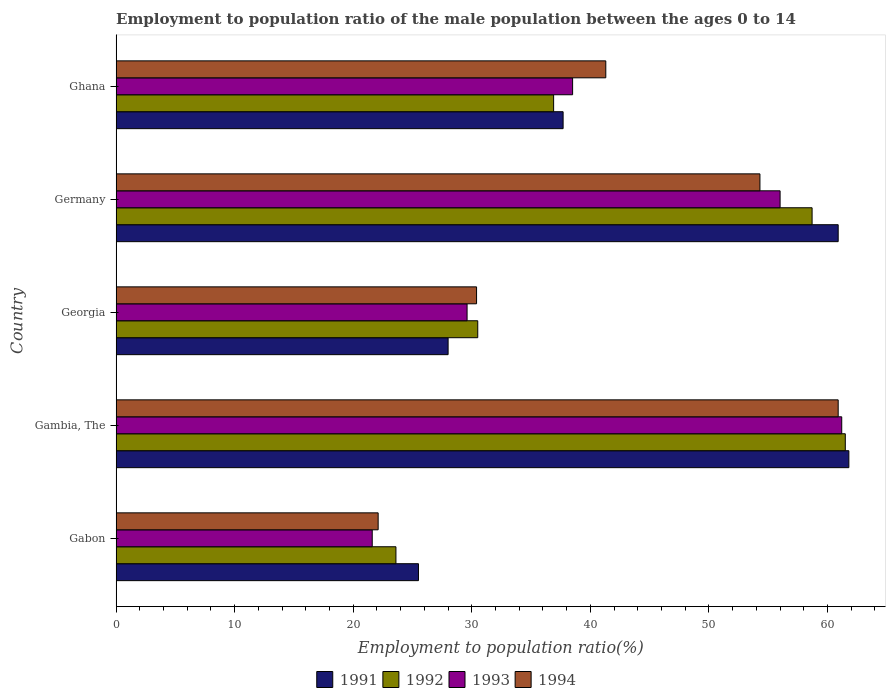How many groups of bars are there?
Provide a short and direct response. 5. How many bars are there on the 1st tick from the top?
Your answer should be compact. 4. In how many cases, is the number of bars for a given country not equal to the number of legend labels?
Offer a terse response. 0. What is the employment to population ratio in 1992 in Germany?
Your response must be concise. 58.7. Across all countries, what is the maximum employment to population ratio in 1991?
Your answer should be compact. 61.8. Across all countries, what is the minimum employment to population ratio in 1993?
Ensure brevity in your answer.  21.6. In which country was the employment to population ratio in 1991 maximum?
Give a very brief answer. Gambia, The. In which country was the employment to population ratio in 1994 minimum?
Ensure brevity in your answer.  Gabon. What is the total employment to population ratio in 1994 in the graph?
Provide a succinct answer. 209. What is the difference between the employment to population ratio in 1994 in Gambia, The and that in Georgia?
Your response must be concise. 30.5. What is the difference between the employment to population ratio in 1993 in Ghana and the employment to population ratio in 1992 in Gabon?
Offer a very short reply. 14.9. What is the average employment to population ratio in 1992 per country?
Your answer should be very brief. 42.24. What is the difference between the employment to population ratio in 1992 and employment to population ratio in 1993 in Georgia?
Your answer should be compact. 0.9. What is the ratio of the employment to population ratio in 1993 in Gabon to that in Gambia, The?
Give a very brief answer. 0.35. What is the difference between the highest and the second highest employment to population ratio in 1992?
Give a very brief answer. 2.8. What is the difference between the highest and the lowest employment to population ratio in 1994?
Offer a terse response. 38.8. Is the sum of the employment to population ratio in 1991 in Gabon and Georgia greater than the maximum employment to population ratio in 1994 across all countries?
Make the answer very short. No. What does the 4th bar from the bottom in Germany represents?
Keep it short and to the point. 1994. How many countries are there in the graph?
Offer a terse response. 5. What is the difference between two consecutive major ticks on the X-axis?
Offer a terse response. 10. Where does the legend appear in the graph?
Ensure brevity in your answer.  Bottom center. What is the title of the graph?
Ensure brevity in your answer.  Employment to population ratio of the male population between the ages 0 to 14. What is the label or title of the X-axis?
Offer a very short reply. Employment to population ratio(%). What is the Employment to population ratio(%) of 1991 in Gabon?
Give a very brief answer. 25.5. What is the Employment to population ratio(%) in 1992 in Gabon?
Your answer should be compact. 23.6. What is the Employment to population ratio(%) in 1993 in Gabon?
Your response must be concise. 21.6. What is the Employment to population ratio(%) of 1994 in Gabon?
Ensure brevity in your answer.  22.1. What is the Employment to population ratio(%) in 1991 in Gambia, The?
Offer a terse response. 61.8. What is the Employment to population ratio(%) of 1992 in Gambia, The?
Offer a terse response. 61.5. What is the Employment to population ratio(%) of 1993 in Gambia, The?
Provide a succinct answer. 61.2. What is the Employment to population ratio(%) of 1994 in Gambia, The?
Your response must be concise. 60.9. What is the Employment to population ratio(%) in 1992 in Georgia?
Make the answer very short. 30.5. What is the Employment to population ratio(%) of 1993 in Georgia?
Your answer should be compact. 29.6. What is the Employment to population ratio(%) in 1994 in Georgia?
Provide a succinct answer. 30.4. What is the Employment to population ratio(%) of 1991 in Germany?
Your answer should be very brief. 60.9. What is the Employment to population ratio(%) in 1992 in Germany?
Your response must be concise. 58.7. What is the Employment to population ratio(%) in 1993 in Germany?
Give a very brief answer. 56. What is the Employment to population ratio(%) of 1994 in Germany?
Make the answer very short. 54.3. What is the Employment to population ratio(%) in 1991 in Ghana?
Keep it short and to the point. 37.7. What is the Employment to population ratio(%) in 1992 in Ghana?
Provide a short and direct response. 36.9. What is the Employment to population ratio(%) in 1993 in Ghana?
Offer a very short reply. 38.5. What is the Employment to population ratio(%) of 1994 in Ghana?
Offer a very short reply. 41.3. Across all countries, what is the maximum Employment to population ratio(%) in 1991?
Provide a succinct answer. 61.8. Across all countries, what is the maximum Employment to population ratio(%) of 1992?
Your answer should be very brief. 61.5. Across all countries, what is the maximum Employment to population ratio(%) of 1993?
Give a very brief answer. 61.2. Across all countries, what is the maximum Employment to population ratio(%) of 1994?
Your answer should be very brief. 60.9. Across all countries, what is the minimum Employment to population ratio(%) of 1992?
Keep it short and to the point. 23.6. Across all countries, what is the minimum Employment to population ratio(%) in 1993?
Your answer should be very brief. 21.6. Across all countries, what is the minimum Employment to population ratio(%) of 1994?
Your answer should be compact. 22.1. What is the total Employment to population ratio(%) in 1991 in the graph?
Make the answer very short. 213.9. What is the total Employment to population ratio(%) in 1992 in the graph?
Ensure brevity in your answer.  211.2. What is the total Employment to population ratio(%) of 1993 in the graph?
Your response must be concise. 206.9. What is the total Employment to population ratio(%) in 1994 in the graph?
Make the answer very short. 209. What is the difference between the Employment to population ratio(%) of 1991 in Gabon and that in Gambia, The?
Give a very brief answer. -36.3. What is the difference between the Employment to population ratio(%) of 1992 in Gabon and that in Gambia, The?
Your response must be concise. -37.9. What is the difference between the Employment to population ratio(%) of 1993 in Gabon and that in Gambia, The?
Your answer should be compact. -39.6. What is the difference between the Employment to population ratio(%) of 1994 in Gabon and that in Gambia, The?
Keep it short and to the point. -38.8. What is the difference between the Employment to population ratio(%) in 1992 in Gabon and that in Georgia?
Your answer should be compact. -6.9. What is the difference between the Employment to population ratio(%) of 1993 in Gabon and that in Georgia?
Provide a succinct answer. -8. What is the difference between the Employment to population ratio(%) of 1991 in Gabon and that in Germany?
Offer a terse response. -35.4. What is the difference between the Employment to population ratio(%) of 1992 in Gabon and that in Germany?
Keep it short and to the point. -35.1. What is the difference between the Employment to population ratio(%) of 1993 in Gabon and that in Germany?
Keep it short and to the point. -34.4. What is the difference between the Employment to population ratio(%) in 1994 in Gabon and that in Germany?
Your response must be concise. -32.2. What is the difference between the Employment to population ratio(%) in 1992 in Gabon and that in Ghana?
Offer a terse response. -13.3. What is the difference between the Employment to population ratio(%) in 1993 in Gabon and that in Ghana?
Offer a terse response. -16.9. What is the difference between the Employment to population ratio(%) in 1994 in Gabon and that in Ghana?
Give a very brief answer. -19.2. What is the difference between the Employment to population ratio(%) of 1991 in Gambia, The and that in Georgia?
Your response must be concise. 33.8. What is the difference between the Employment to population ratio(%) in 1993 in Gambia, The and that in Georgia?
Give a very brief answer. 31.6. What is the difference between the Employment to population ratio(%) in 1994 in Gambia, The and that in Georgia?
Offer a terse response. 30.5. What is the difference between the Employment to population ratio(%) of 1993 in Gambia, The and that in Germany?
Make the answer very short. 5.2. What is the difference between the Employment to population ratio(%) of 1991 in Gambia, The and that in Ghana?
Keep it short and to the point. 24.1. What is the difference between the Employment to population ratio(%) of 1992 in Gambia, The and that in Ghana?
Your answer should be compact. 24.6. What is the difference between the Employment to population ratio(%) of 1993 in Gambia, The and that in Ghana?
Give a very brief answer. 22.7. What is the difference between the Employment to population ratio(%) of 1994 in Gambia, The and that in Ghana?
Offer a very short reply. 19.6. What is the difference between the Employment to population ratio(%) in 1991 in Georgia and that in Germany?
Give a very brief answer. -32.9. What is the difference between the Employment to population ratio(%) in 1992 in Georgia and that in Germany?
Give a very brief answer. -28.2. What is the difference between the Employment to population ratio(%) in 1993 in Georgia and that in Germany?
Provide a succinct answer. -26.4. What is the difference between the Employment to population ratio(%) of 1994 in Georgia and that in Germany?
Offer a terse response. -23.9. What is the difference between the Employment to population ratio(%) of 1992 in Georgia and that in Ghana?
Ensure brevity in your answer.  -6.4. What is the difference between the Employment to population ratio(%) of 1993 in Georgia and that in Ghana?
Offer a very short reply. -8.9. What is the difference between the Employment to population ratio(%) of 1991 in Germany and that in Ghana?
Ensure brevity in your answer.  23.2. What is the difference between the Employment to population ratio(%) in 1992 in Germany and that in Ghana?
Offer a very short reply. 21.8. What is the difference between the Employment to population ratio(%) in 1991 in Gabon and the Employment to population ratio(%) in 1992 in Gambia, The?
Your response must be concise. -36. What is the difference between the Employment to population ratio(%) in 1991 in Gabon and the Employment to population ratio(%) in 1993 in Gambia, The?
Give a very brief answer. -35.7. What is the difference between the Employment to population ratio(%) in 1991 in Gabon and the Employment to population ratio(%) in 1994 in Gambia, The?
Keep it short and to the point. -35.4. What is the difference between the Employment to population ratio(%) in 1992 in Gabon and the Employment to population ratio(%) in 1993 in Gambia, The?
Give a very brief answer. -37.6. What is the difference between the Employment to population ratio(%) in 1992 in Gabon and the Employment to population ratio(%) in 1994 in Gambia, The?
Ensure brevity in your answer.  -37.3. What is the difference between the Employment to population ratio(%) in 1993 in Gabon and the Employment to population ratio(%) in 1994 in Gambia, The?
Provide a succinct answer. -39.3. What is the difference between the Employment to population ratio(%) of 1991 in Gabon and the Employment to population ratio(%) of 1992 in Germany?
Offer a very short reply. -33.2. What is the difference between the Employment to population ratio(%) of 1991 in Gabon and the Employment to population ratio(%) of 1993 in Germany?
Make the answer very short. -30.5. What is the difference between the Employment to population ratio(%) of 1991 in Gabon and the Employment to population ratio(%) of 1994 in Germany?
Your response must be concise. -28.8. What is the difference between the Employment to population ratio(%) in 1992 in Gabon and the Employment to population ratio(%) in 1993 in Germany?
Provide a short and direct response. -32.4. What is the difference between the Employment to population ratio(%) in 1992 in Gabon and the Employment to population ratio(%) in 1994 in Germany?
Provide a short and direct response. -30.7. What is the difference between the Employment to population ratio(%) in 1993 in Gabon and the Employment to population ratio(%) in 1994 in Germany?
Give a very brief answer. -32.7. What is the difference between the Employment to population ratio(%) of 1991 in Gabon and the Employment to population ratio(%) of 1992 in Ghana?
Keep it short and to the point. -11.4. What is the difference between the Employment to population ratio(%) in 1991 in Gabon and the Employment to population ratio(%) in 1993 in Ghana?
Offer a terse response. -13. What is the difference between the Employment to population ratio(%) in 1991 in Gabon and the Employment to population ratio(%) in 1994 in Ghana?
Your response must be concise. -15.8. What is the difference between the Employment to population ratio(%) in 1992 in Gabon and the Employment to population ratio(%) in 1993 in Ghana?
Give a very brief answer. -14.9. What is the difference between the Employment to population ratio(%) of 1992 in Gabon and the Employment to population ratio(%) of 1994 in Ghana?
Make the answer very short. -17.7. What is the difference between the Employment to population ratio(%) of 1993 in Gabon and the Employment to population ratio(%) of 1994 in Ghana?
Ensure brevity in your answer.  -19.7. What is the difference between the Employment to population ratio(%) in 1991 in Gambia, The and the Employment to population ratio(%) in 1992 in Georgia?
Keep it short and to the point. 31.3. What is the difference between the Employment to population ratio(%) in 1991 in Gambia, The and the Employment to population ratio(%) in 1993 in Georgia?
Provide a short and direct response. 32.2. What is the difference between the Employment to population ratio(%) in 1991 in Gambia, The and the Employment to population ratio(%) in 1994 in Georgia?
Provide a succinct answer. 31.4. What is the difference between the Employment to population ratio(%) in 1992 in Gambia, The and the Employment to population ratio(%) in 1993 in Georgia?
Give a very brief answer. 31.9. What is the difference between the Employment to population ratio(%) in 1992 in Gambia, The and the Employment to population ratio(%) in 1994 in Georgia?
Your answer should be very brief. 31.1. What is the difference between the Employment to population ratio(%) in 1993 in Gambia, The and the Employment to population ratio(%) in 1994 in Georgia?
Your answer should be very brief. 30.8. What is the difference between the Employment to population ratio(%) of 1991 in Gambia, The and the Employment to population ratio(%) of 1992 in Germany?
Your answer should be very brief. 3.1. What is the difference between the Employment to population ratio(%) in 1992 in Gambia, The and the Employment to population ratio(%) in 1993 in Germany?
Your answer should be very brief. 5.5. What is the difference between the Employment to population ratio(%) in 1992 in Gambia, The and the Employment to population ratio(%) in 1994 in Germany?
Your answer should be very brief. 7.2. What is the difference between the Employment to population ratio(%) of 1991 in Gambia, The and the Employment to population ratio(%) of 1992 in Ghana?
Provide a succinct answer. 24.9. What is the difference between the Employment to population ratio(%) of 1991 in Gambia, The and the Employment to population ratio(%) of 1993 in Ghana?
Your answer should be compact. 23.3. What is the difference between the Employment to population ratio(%) in 1991 in Gambia, The and the Employment to population ratio(%) in 1994 in Ghana?
Your answer should be compact. 20.5. What is the difference between the Employment to population ratio(%) of 1992 in Gambia, The and the Employment to population ratio(%) of 1993 in Ghana?
Your answer should be compact. 23. What is the difference between the Employment to population ratio(%) in 1992 in Gambia, The and the Employment to population ratio(%) in 1994 in Ghana?
Your answer should be very brief. 20.2. What is the difference between the Employment to population ratio(%) in 1991 in Georgia and the Employment to population ratio(%) in 1992 in Germany?
Your answer should be very brief. -30.7. What is the difference between the Employment to population ratio(%) of 1991 in Georgia and the Employment to population ratio(%) of 1993 in Germany?
Offer a very short reply. -28. What is the difference between the Employment to population ratio(%) of 1991 in Georgia and the Employment to population ratio(%) of 1994 in Germany?
Your response must be concise. -26.3. What is the difference between the Employment to population ratio(%) of 1992 in Georgia and the Employment to population ratio(%) of 1993 in Germany?
Your answer should be compact. -25.5. What is the difference between the Employment to population ratio(%) of 1992 in Georgia and the Employment to population ratio(%) of 1994 in Germany?
Ensure brevity in your answer.  -23.8. What is the difference between the Employment to population ratio(%) in 1993 in Georgia and the Employment to population ratio(%) in 1994 in Germany?
Ensure brevity in your answer.  -24.7. What is the difference between the Employment to population ratio(%) of 1991 in Georgia and the Employment to population ratio(%) of 1992 in Ghana?
Ensure brevity in your answer.  -8.9. What is the difference between the Employment to population ratio(%) of 1991 in Georgia and the Employment to population ratio(%) of 1993 in Ghana?
Make the answer very short. -10.5. What is the difference between the Employment to population ratio(%) in 1992 in Georgia and the Employment to population ratio(%) in 1993 in Ghana?
Your response must be concise. -8. What is the difference between the Employment to population ratio(%) of 1991 in Germany and the Employment to population ratio(%) of 1992 in Ghana?
Your answer should be very brief. 24. What is the difference between the Employment to population ratio(%) of 1991 in Germany and the Employment to population ratio(%) of 1993 in Ghana?
Give a very brief answer. 22.4. What is the difference between the Employment to population ratio(%) of 1991 in Germany and the Employment to population ratio(%) of 1994 in Ghana?
Ensure brevity in your answer.  19.6. What is the difference between the Employment to population ratio(%) in 1992 in Germany and the Employment to population ratio(%) in 1993 in Ghana?
Ensure brevity in your answer.  20.2. What is the average Employment to population ratio(%) of 1991 per country?
Offer a terse response. 42.78. What is the average Employment to population ratio(%) of 1992 per country?
Provide a succinct answer. 42.24. What is the average Employment to population ratio(%) in 1993 per country?
Ensure brevity in your answer.  41.38. What is the average Employment to population ratio(%) of 1994 per country?
Make the answer very short. 41.8. What is the difference between the Employment to population ratio(%) in 1991 and Employment to population ratio(%) in 1992 in Gabon?
Offer a very short reply. 1.9. What is the difference between the Employment to population ratio(%) of 1991 and Employment to population ratio(%) of 1993 in Gabon?
Keep it short and to the point. 3.9. What is the difference between the Employment to population ratio(%) of 1992 and Employment to population ratio(%) of 1993 in Gabon?
Make the answer very short. 2. What is the difference between the Employment to population ratio(%) in 1992 and Employment to population ratio(%) in 1994 in Gabon?
Your answer should be compact. 1.5. What is the difference between the Employment to population ratio(%) in 1993 and Employment to population ratio(%) in 1994 in Gabon?
Provide a succinct answer. -0.5. What is the difference between the Employment to population ratio(%) in 1991 and Employment to population ratio(%) in 1992 in Gambia, The?
Offer a terse response. 0.3. What is the difference between the Employment to population ratio(%) in 1991 and Employment to population ratio(%) in 1993 in Gambia, The?
Offer a very short reply. 0.6. What is the difference between the Employment to population ratio(%) in 1992 and Employment to population ratio(%) in 1994 in Gambia, The?
Offer a very short reply. 0.6. What is the difference between the Employment to population ratio(%) in 1993 and Employment to population ratio(%) in 1994 in Gambia, The?
Give a very brief answer. 0.3. What is the difference between the Employment to population ratio(%) of 1991 and Employment to population ratio(%) of 1992 in Georgia?
Offer a terse response. -2.5. What is the difference between the Employment to population ratio(%) in 1992 and Employment to population ratio(%) in 1993 in Georgia?
Your answer should be compact. 0.9. What is the difference between the Employment to population ratio(%) of 1992 and Employment to population ratio(%) of 1994 in Georgia?
Provide a succinct answer. 0.1. What is the difference between the Employment to population ratio(%) in 1993 and Employment to population ratio(%) in 1994 in Georgia?
Make the answer very short. -0.8. What is the difference between the Employment to population ratio(%) in 1991 and Employment to population ratio(%) in 1992 in Germany?
Offer a terse response. 2.2. What is the difference between the Employment to population ratio(%) in 1991 and Employment to population ratio(%) in 1993 in Germany?
Your answer should be very brief. 4.9. What is the difference between the Employment to population ratio(%) in 1991 and Employment to population ratio(%) in 1994 in Germany?
Ensure brevity in your answer.  6.6. What is the difference between the Employment to population ratio(%) in 1991 and Employment to population ratio(%) in 1993 in Ghana?
Provide a short and direct response. -0.8. What is the difference between the Employment to population ratio(%) of 1991 and Employment to population ratio(%) of 1994 in Ghana?
Keep it short and to the point. -3.6. What is the difference between the Employment to population ratio(%) in 1992 and Employment to population ratio(%) in 1993 in Ghana?
Make the answer very short. -1.6. What is the difference between the Employment to population ratio(%) in 1992 and Employment to population ratio(%) in 1994 in Ghana?
Your answer should be very brief. -4.4. What is the ratio of the Employment to population ratio(%) in 1991 in Gabon to that in Gambia, The?
Provide a short and direct response. 0.41. What is the ratio of the Employment to population ratio(%) of 1992 in Gabon to that in Gambia, The?
Your response must be concise. 0.38. What is the ratio of the Employment to population ratio(%) in 1993 in Gabon to that in Gambia, The?
Your response must be concise. 0.35. What is the ratio of the Employment to population ratio(%) of 1994 in Gabon to that in Gambia, The?
Provide a short and direct response. 0.36. What is the ratio of the Employment to population ratio(%) in 1991 in Gabon to that in Georgia?
Make the answer very short. 0.91. What is the ratio of the Employment to population ratio(%) of 1992 in Gabon to that in Georgia?
Keep it short and to the point. 0.77. What is the ratio of the Employment to population ratio(%) of 1993 in Gabon to that in Georgia?
Make the answer very short. 0.73. What is the ratio of the Employment to population ratio(%) of 1994 in Gabon to that in Georgia?
Keep it short and to the point. 0.73. What is the ratio of the Employment to population ratio(%) of 1991 in Gabon to that in Germany?
Give a very brief answer. 0.42. What is the ratio of the Employment to population ratio(%) in 1992 in Gabon to that in Germany?
Keep it short and to the point. 0.4. What is the ratio of the Employment to population ratio(%) in 1993 in Gabon to that in Germany?
Provide a short and direct response. 0.39. What is the ratio of the Employment to population ratio(%) of 1994 in Gabon to that in Germany?
Keep it short and to the point. 0.41. What is the ratio of the Employment to population ratio(%) of 1991 in Gabon to that in Ghana?
Give a very brief answer. 0.68. What is the ratio of the Employment to population ratio(%) in 1992 in Gabon to that in Ghana?
Your response must be concise. 0.64. What is the ratio of the Employment to population ratio(%) in 1993 in Gabon to that in Ghana?
Make the answer very short. 0.56. What is the ratio of the Employment to population ratio(%) of 1994 in Gabon to that in Ghana?
Keep it short and to the point. 0.54. What is the ratio of the Employment to population ratio(%) in 1991 in Gambia, The to that in Georgia?
Your answer should be compact. 2.21. What is the ratio of the Employment to population ratio(%) of 1992 in Gambia, The to that in Georgia?
Your answer should be compact. 2.02. What is the ratio of the Employment to population ratio(%) in 1993 in Gambia, The to that in Georgia?
Your answer should be compact. 2.07. What is the ratio of the Employment to population ratio(%) in 1994 in Gambia, The to that in Georgia?
Offer a terse response. 2. What is the ratio of the Employment to population ratio(%) of 1991 in Gambia, The to that in Germany?
Provide a short and direct response. 1.01. What is the ratio of the Employment to population ratio(%) in 1992 in Gambia, The to that in Germany?
Provide a short and direct response. 1.05. What is the ratio of the Employment to population ratio(%) in 1993 in Gambia, The to that in Germany?
Offer a terse response. 1.09. What is the ratio of the Employment to population ratio(%) of 1994 in Gambia, The to that in Germany?
Your answer should be compact. 1.12. What is the ratio of the Employment to population ratio(%) of 1991 in Gambia, The to that in Ghana?
Keep it short and to the point. 1.64. What is the ratio of the Employment to population ratio(%) in 1992 in Gambia, The to that in Ghana?
Your response must be concise. 1.67. What is the ratio of the Employment to population ratio(%) of 1993 in Gambia, The to that in Ghana?
Offer a terse response. 1.59. What is the ratio of the Employment to population ratio(%) in 1994 in Gambia, The to that in Ghana?
Make the answer very short. 1.47. What is the ratio of the Employment to population ratio(%) of 1991 in Georgia to that in Germany?
Your response must be concise. 0.46. What is the ratio of the Employment to population ratio(%) of 1992 in Georgia to that in Germany?
Offer a very short reply. 0.52. What is the ratio of the Employment to population ratio(%) of 1993 in Georgia to that in Germany?
Provide a succinct answer. 0.53. What is the ratio of the Employment to population ratio(%) of 1994 in Georgia to that in Germany?
Provide a succinct answer. 0.56. What is the ratio of the Employment to population ratio(%) of 1991 in Georgia to that in Ghana?
Keep it short and to the point. 0.74. What is the ratio of the Employment to population ratio(%) of 1992 in Georgia to that in Ghana?
Provide a succinct answer. 0.83. What is the ratio of the Employment to population ratio(%) in 1993 in Georgia to that in Ghana?
Offer a very short reply. 0.77. What is the ratio of the Employment to population ratio(%) in 1994 in Georgia to that in Ghana?
Your response must be concise. 0.74. What is the ratio of the Employment to population ratio(%) in 1991 in Germany to that in Ghana?
Your answer should be very brief. 1.62. What is the ratio of the Employment to population ratio(%) in 1992 in Germany to that in Ghana?
Ensure brevity in your answer.  1.59. What is the ratio of the Employment to population ratio(%) of 1993 in Germany to that in Ghana?
Provide a succinct answer. 1.45. What is the ratio of the Employment to population ratio(%) of 1994 in Germany to that in Ghana?
Your answer should be very brief. 1.31. What is the difference between the highest and the second highest Employment to population ratio(%) in 1992?
Provide a short and direct response. 2.8. What is the difference between the highest and the second highest Employment to population ratio(%) in 1994?
Give a very brief answer. 6.6. What is the difference between the highest and the lowest Employment to population ratio(%) of 1991?
Offer a very short reply. 36.3. What is the difference between the highest and the lowest Employment to population ratio(%) of 1992?
Give a very brief answer. 37.9. What is the difference between the highest and the lowest Employment to population ratio(%) of 1993?
Make the answer very short. 39.6. What is the difference between the highest and the lowest Employment to population ratio(%) in 1994?
Make the answer very short. 38.8. 